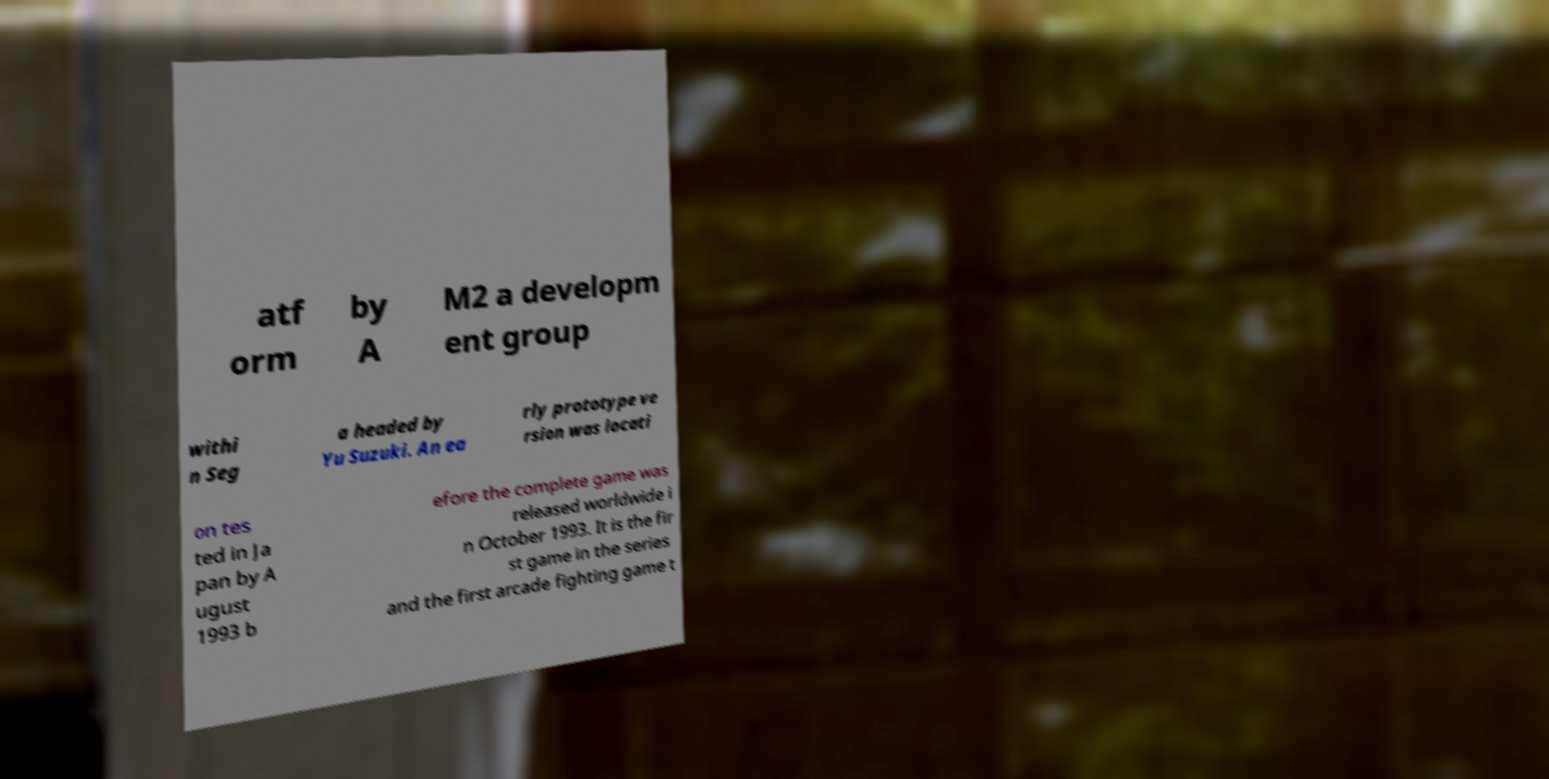Can you read and provide the text displayed in the image?This photo seems to have some interesting text. Can you extract and type it out for me? atf orm by A M2 a developm ent group withi n Seg a headed by Yu Suzuki. An ea rly prototype ve rsion was locati on tes ted in Ja pan by A ugust 1993 b efore the complete game was released worldwide i n October 1993. It is the fir st game in the series and the first arcade fighting game t 